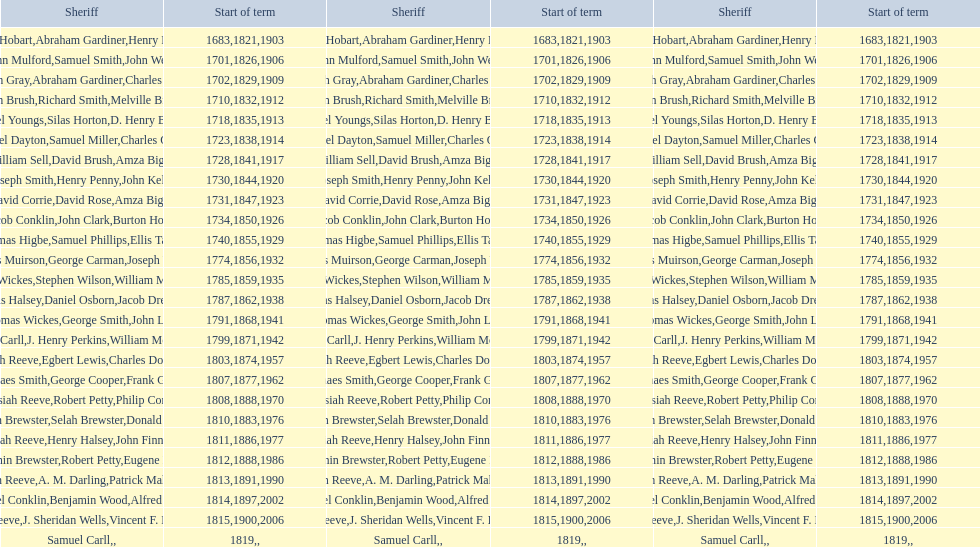Was robert petty serving prior to josiah reeve? No. 